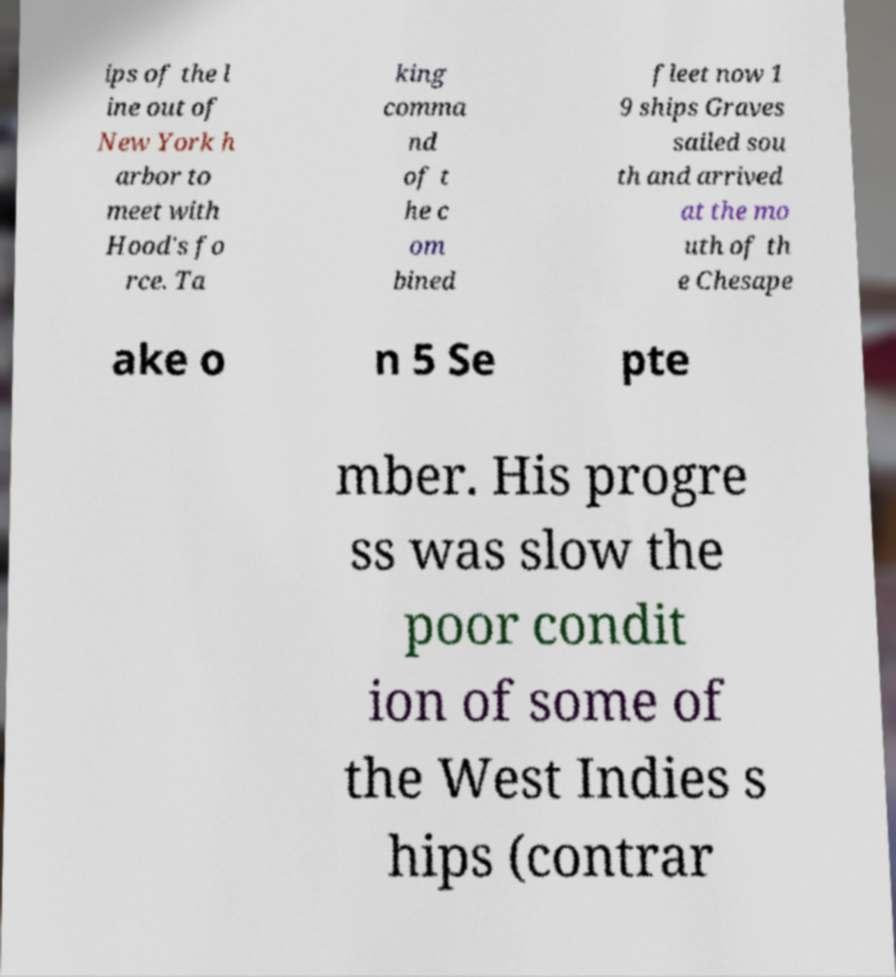What messages or text are displayed in this image? I need them in a readable, typed format. ips of the l ine out of New York h arbor to meet with Hood's fo rce. Ta king comma nd of t he c om bined fleet now 1 9 ships Graves sailed sou th and arrived at the mo uth of th e Chesape ake o n 5 Se pte mber. His progre ss was slow the poor condit ion of some of the West Indies s hips (contrar 